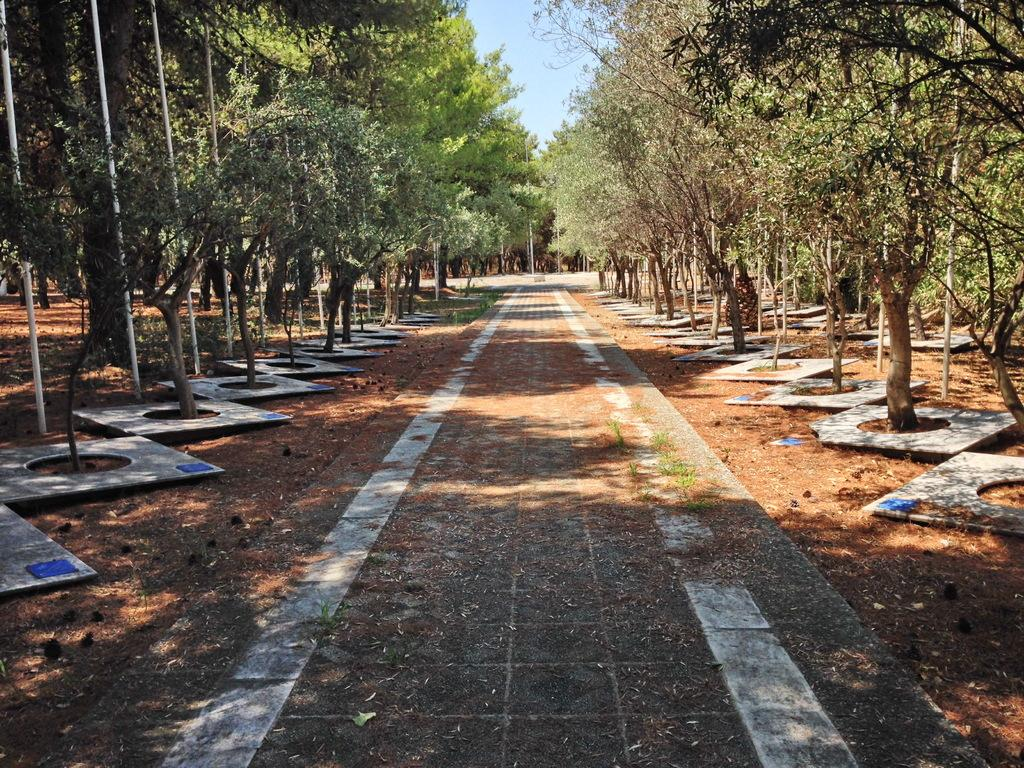What type of vegetation can be seen in the image? There are trees in the image. What else is present in the image besides trees? There are poles in the image. What can be seen above the trees and poles in the image? The sky is visible in the image. What type of seed can be seen growing on the poles in the image? There are no seeds visible on the poles in the image. How does the wire connect the poles in the image? There is no wire connecting the poles in the image. 